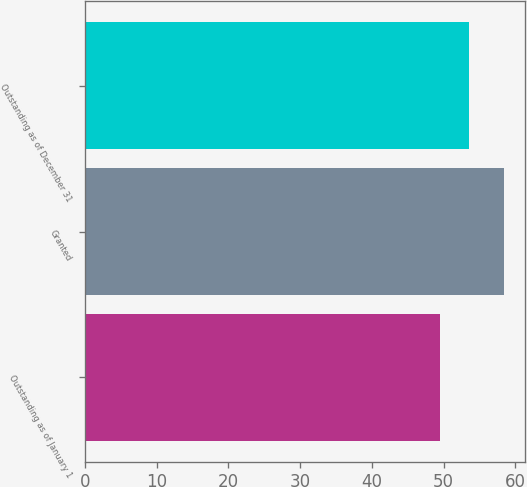<chart> <loc_0><loc_0><loc_500><loc_500><bar_chart><fcel>Outstanding as of January 1<fcel>Granted<fcel>Outstanding as of December 31<nl><fcel>49.54<fcel>58.4<fcel>53.56<nl></chart> 